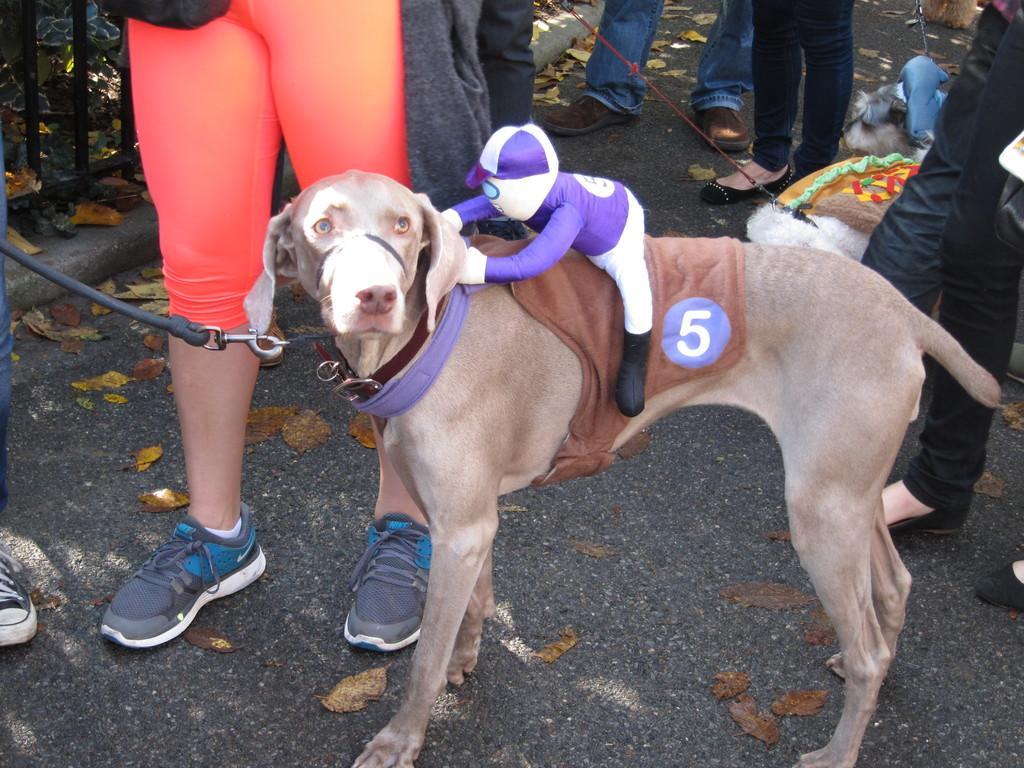How would you summarize this image in a sentence or two? In this image we can see the dogs and the legs of the persons, there are some leaves on the ground, also we can see the fence and a toy on the dog. 